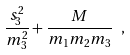<formula> <loc_0><loc_0><loc_500><loc_500>\frac { s _ { 3 } ^ { 2 } } { m _ { 3 } ^ { 2 } } + \frac { M } { m _ { 1 } m _ { 2 } m _ { 3 } } \ ,</formula> 